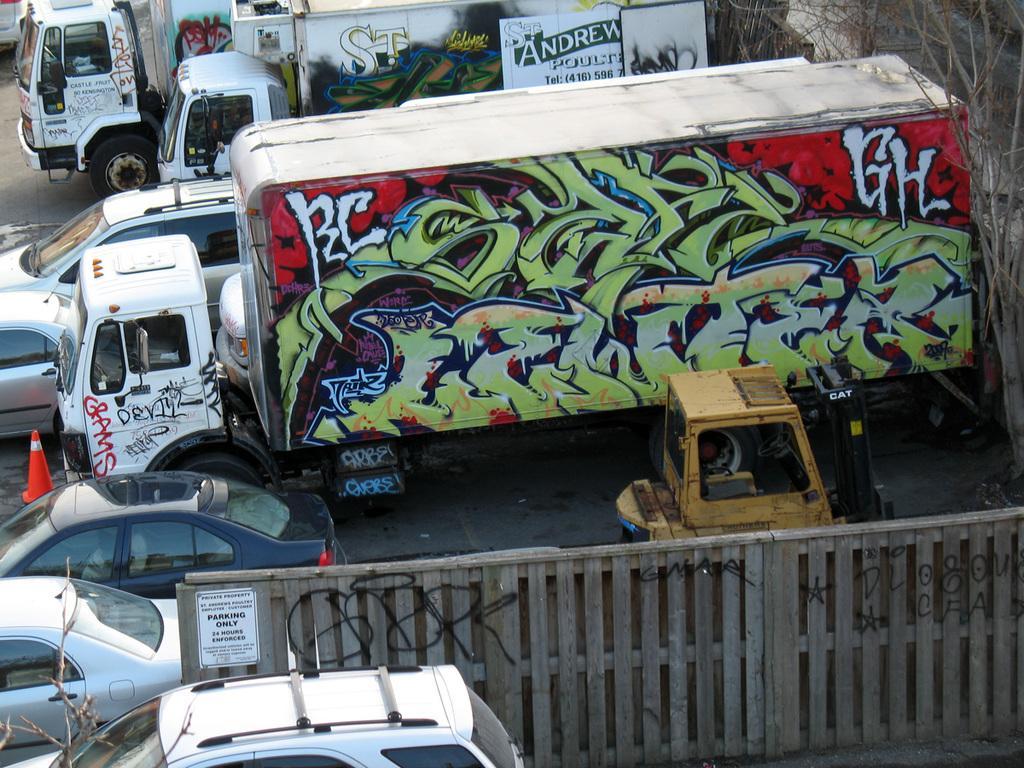In one or two sentences, can you explain what this image depicts? There are many cars and trucks. On the left side there is a truck. On the truck there is graffiti. Also there is a railing. On the right side there are trees. 